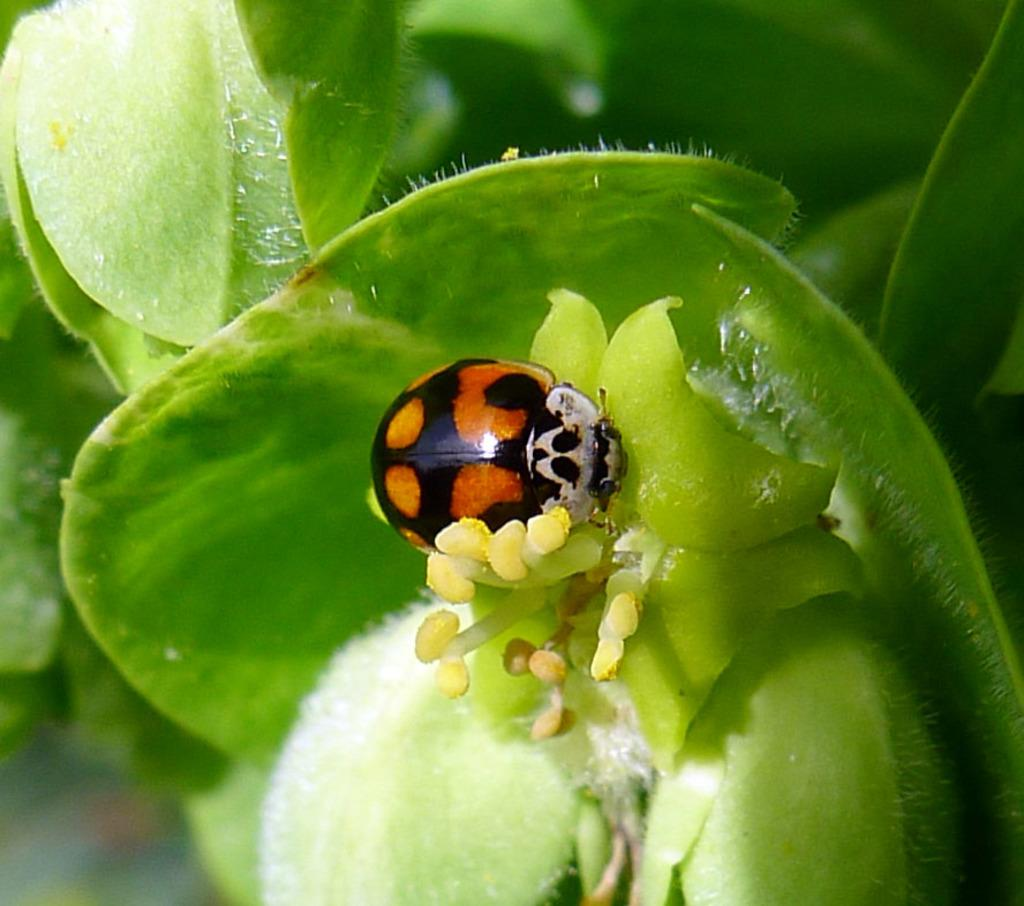What is on the flower in the image? There is an insect on a flower in the image. What else can be seen in the image besides the insect and flower? There are plants in the image. Can you describe the background of the image? The background of the image is blurred. What type of creature can be seen jumping out of the cave in the image? There is no creature or cave present in the image; it features an insect on a flower with plants in the background. 